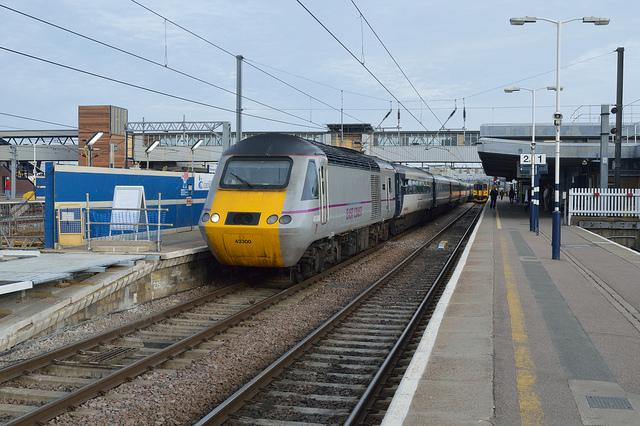Which train is safest to board for those on our right? Please explain your reasoning. near arriving. They will be safe if they board the one that is incoming and closest to the loading dock that they are standing on. 